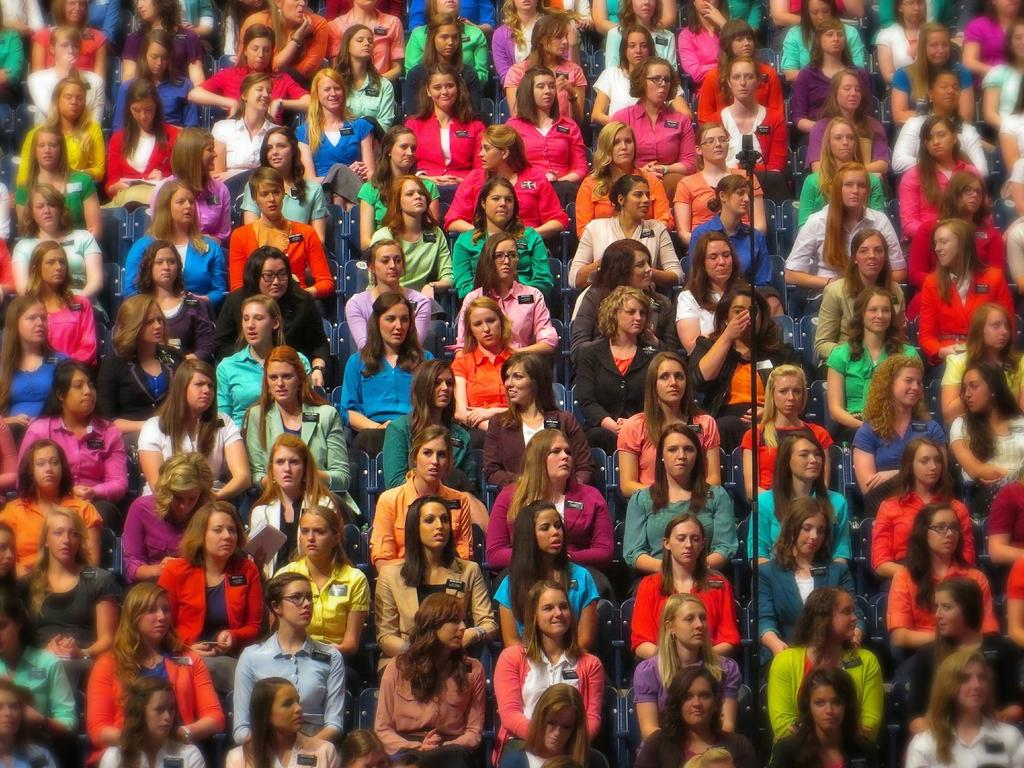Who is present in the image? There are girls in the image. What are the girls doing in the image? The girls are sitting on chairs. What is the thumb of the girl on the left doing in the image? There is no thumb or specific action of a thumb mentioned in the image; it only states that the girls are sitting on chairs. 